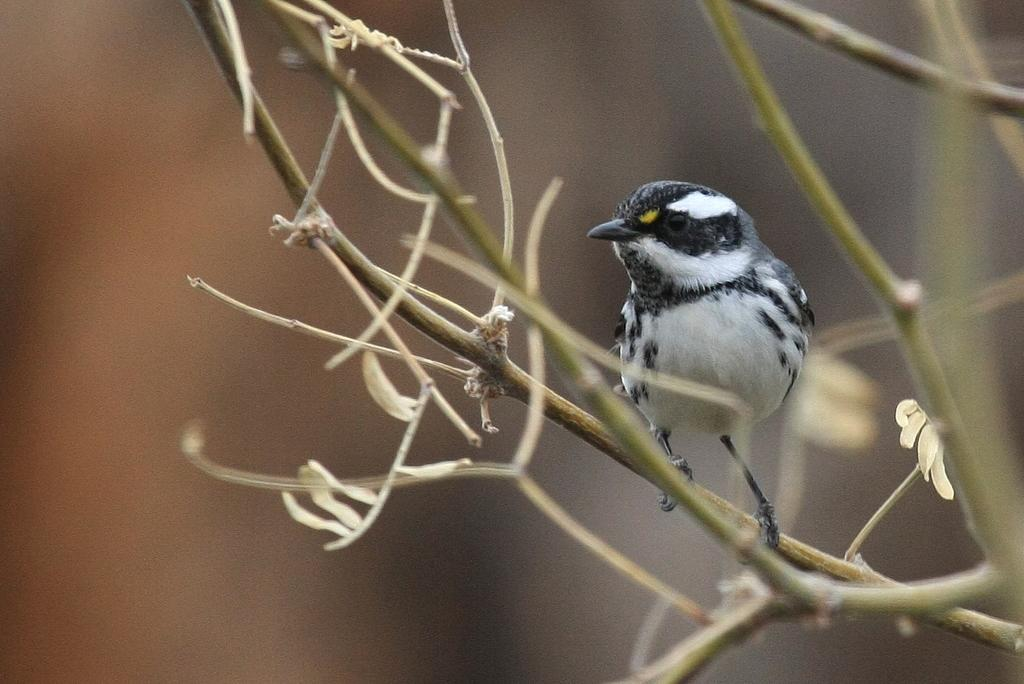What type of animal can be seen in the image? There is a bird in the image. Where is the bird located in the image? The bird is standing on branches. What type of fowl can be seen downtown in the image? There is no mention of a fowl or a downtown location in the image. The image only features a bird standing on branches. 